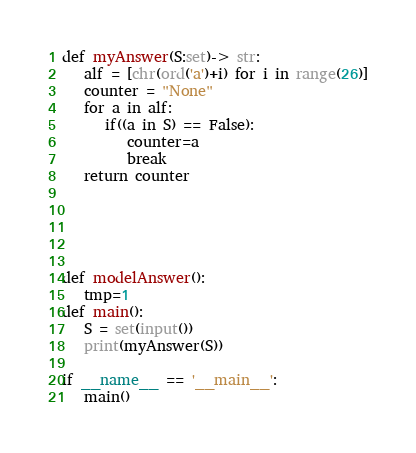<code> <loc_0><loc_0><loc_500><loc_500><_Python_>def myAnswer(S:set)-> str:
   alf = [chr(ord('a')+i) for i in range(26)]
   counter = "None"
   for a in alf:
      if((a in S) == False):
         counter=a
         break
   return counter



   

def modelAnswer():
   tmp=1
def main():
   S = set(input())
   print(myAnswer(S))

if __name__ == '__main__':
   main()</code> 